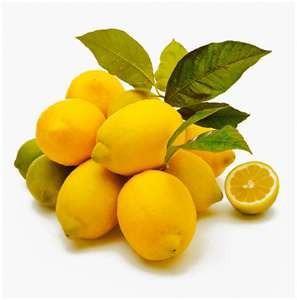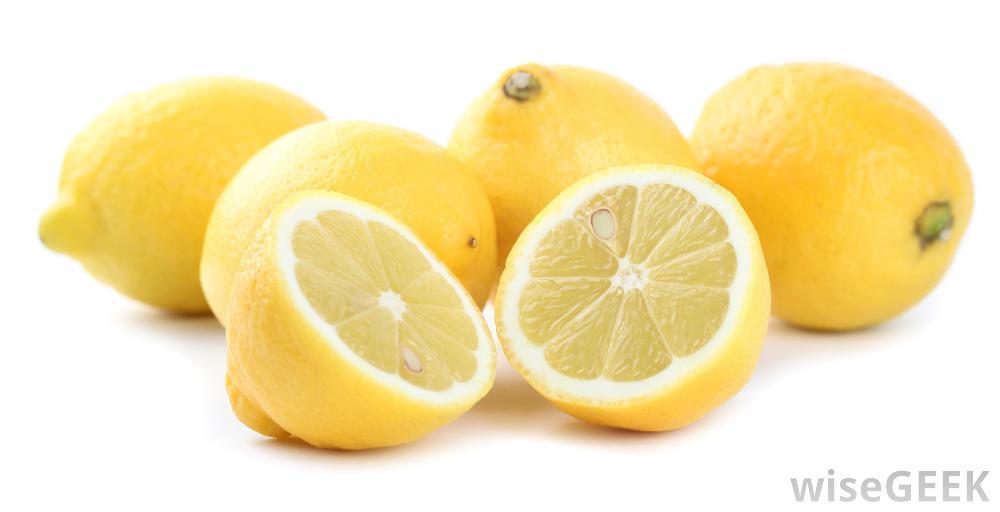The first image is the image on the left, the second image is the image on the right. Evaluate the accuracy of this statement regarding the images: "The combined images include at least one cut lemon half and multiple whole lemons, but no lemons are in a container.". Is it true? Answer yes or no. Yes. The first image is the image on the left, the second image is the image on the right. Analyze the images presented: Is the assertion "There are only whole uncut lemons in the left image." valid? Answer yes or no. No. 